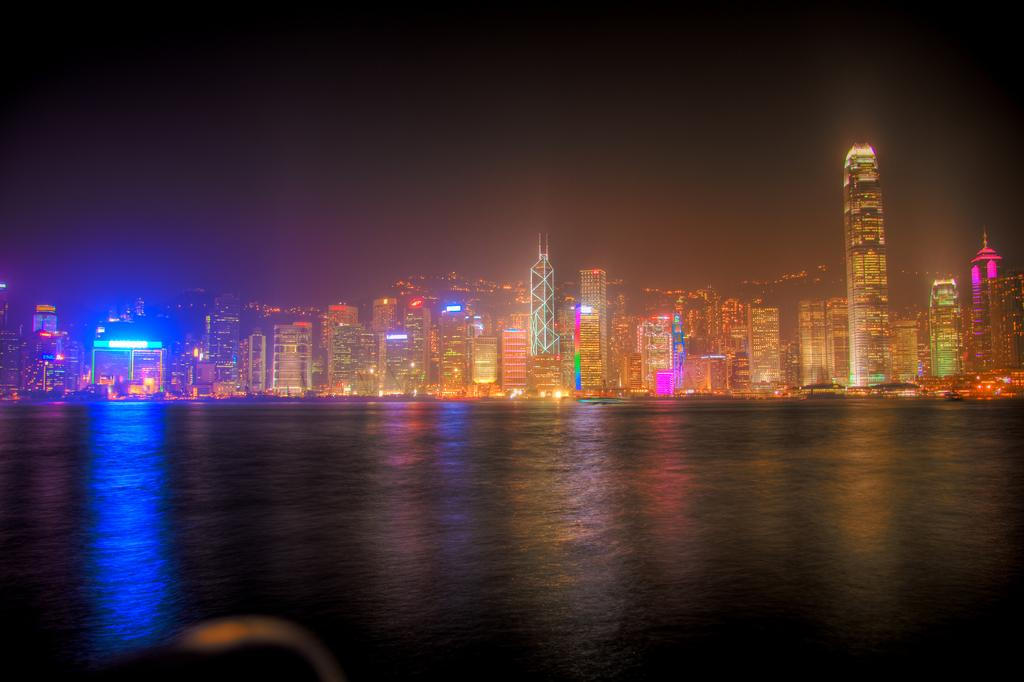What is visible in the image? Water is visible in the image. What can be seen in the background of the image? There are buildings, lights, and the sky visible in the background of the image. What type of wren can be seen perched on the ring in the image? There is no wren or ring present in the image. 